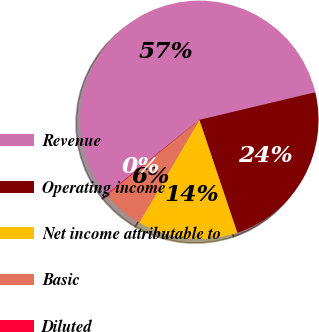Convert chart to OTSL. <chart><loc_0><loc_0><loc_500><loc_500><pie_chart><fcel>Revenue<fcel>Operating income<fcel>Net income attributable to<fcel>Basic<fcel>Diluted<nl><fcel>57.05%<fcel>23.56%<fcel>13.58%<fcel>5.76%<fcel>0.06%<nl></chart> 